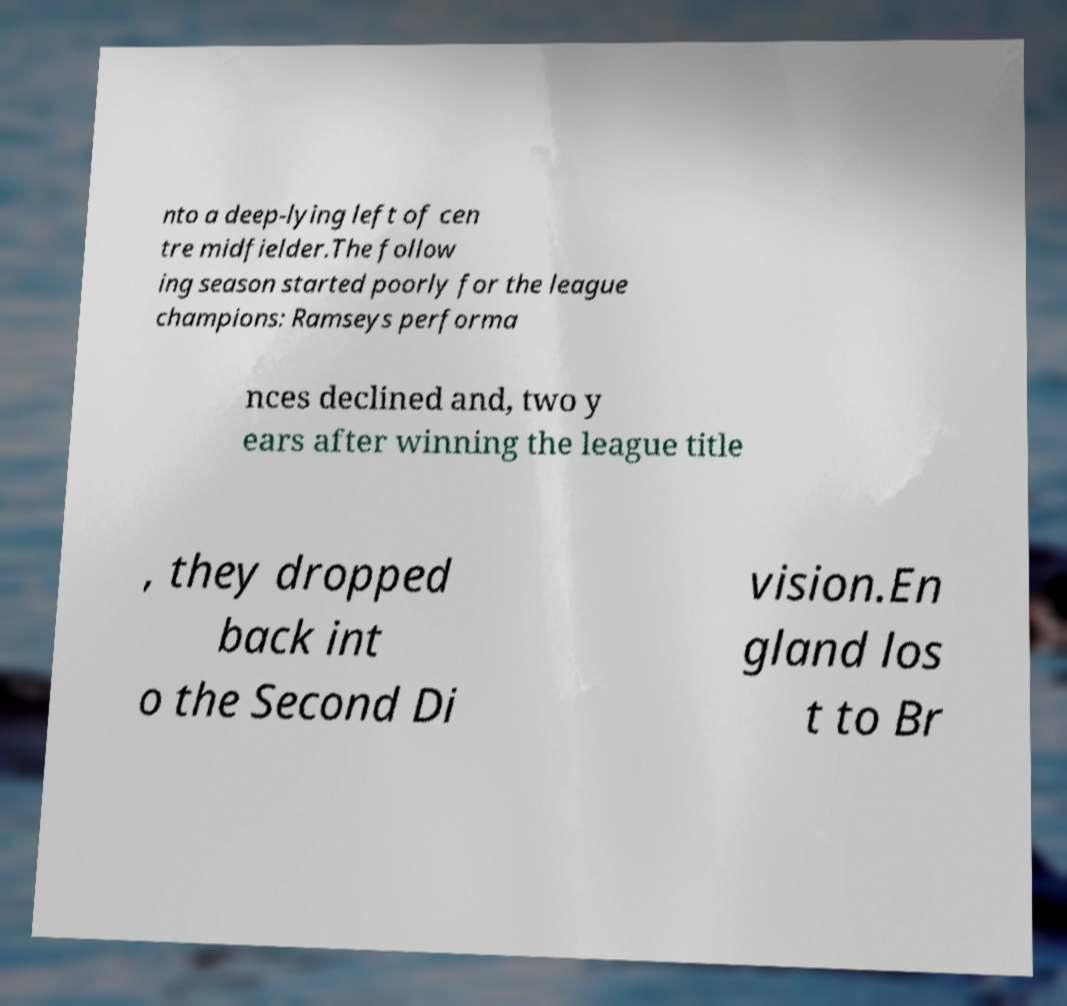Can you accurately transcribe the text from the provided image for me? nto a deep-lying left of cen tre midfielder.The follow ing season started poorly for the league champions: Ramseys performa nces declined and, two y ears after winning the league title , they dropped back int o the Second Di vision.En gland los t to Br 